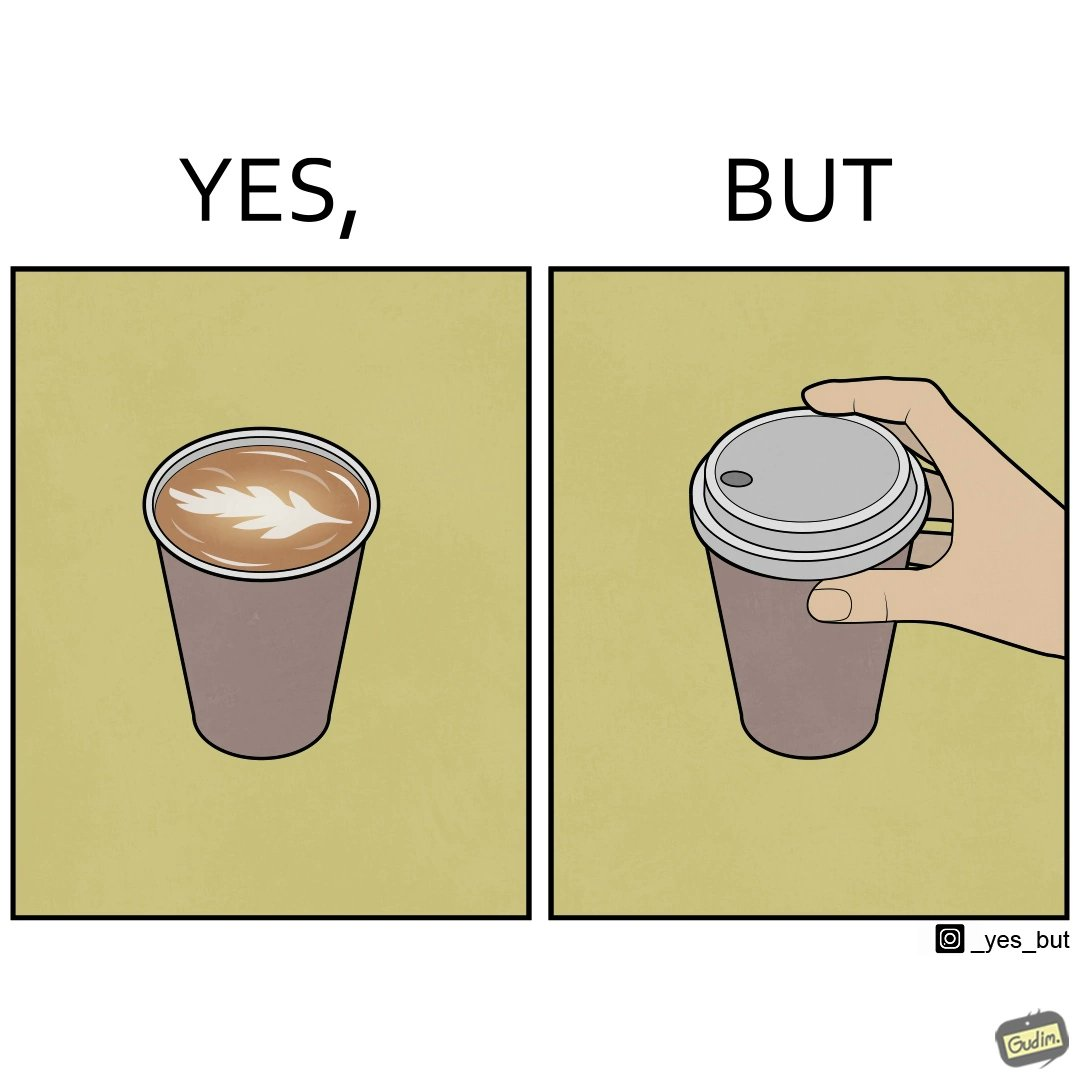Describe what you see in this image. The images are funny since it shows how someone has put effort into a cup of coffee to do latte art on it only for it to be invisible after a lid is put on the coffee cup before serving to a customer 